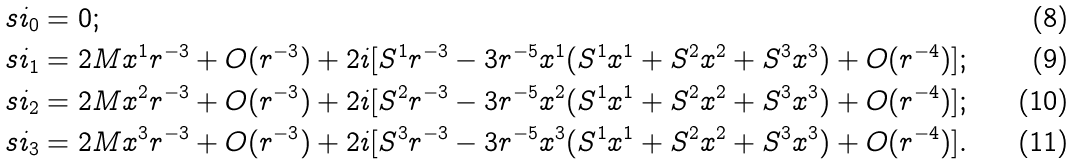Convert formula to latex. <formula><loc_0><loc_0><loc_500><loc_500>& \ s i _ { 0 } = 0 ; \\ & \ s i _ { 1 } = 2 M x ^ { 1 } r ^ { - 3 } + O ( r ^ { - 3 } ) + 2 i [ S ^ { 1 } r ^ { - 3 } - 3 r ^ { - 5 } x ^ { 1 } ( S ^ { 1 } x ^ { 1 } + S ^ { 2 } x ^ { 2 } + S ^ { 3 } x ^ { 3 } ) + O ( r ^ { - 4 } ) ] ; \\ & \ s i _ { 2 } = 2 M x ^ { 2 } r ^ { - 3 } + O ( r ^ { - 3 } ) + 2 i [ S ^ { 2 } r ^ { - 3 } - 3 r ^ { - 5 } x ^ { 2 } ( S ^ { 1 } x ^ { 1 } + S ^ { 2 } x ^ { 2 } + S ^ { 3 } x ^ { 3 } ) + O ( r ^ { - 4 } ) ] ; \\ & \ s i _ { 3 } = 2 M x ^ { 3 } r ^ { - 3 } + O ( r ^ { - 3 } ) + 2 i [ S ^ { 3 } r ^ { - 3 } - 3 r ^ { - 5 } x ^ { 3 } ( S ^ { 1 } x ^ { 1 } + S ^ { 2 } x ^ { 2 } + S ^ { 3 } x ^ { 3 } ) + O ( r ^ { - 4 } ) ] .</formula> 